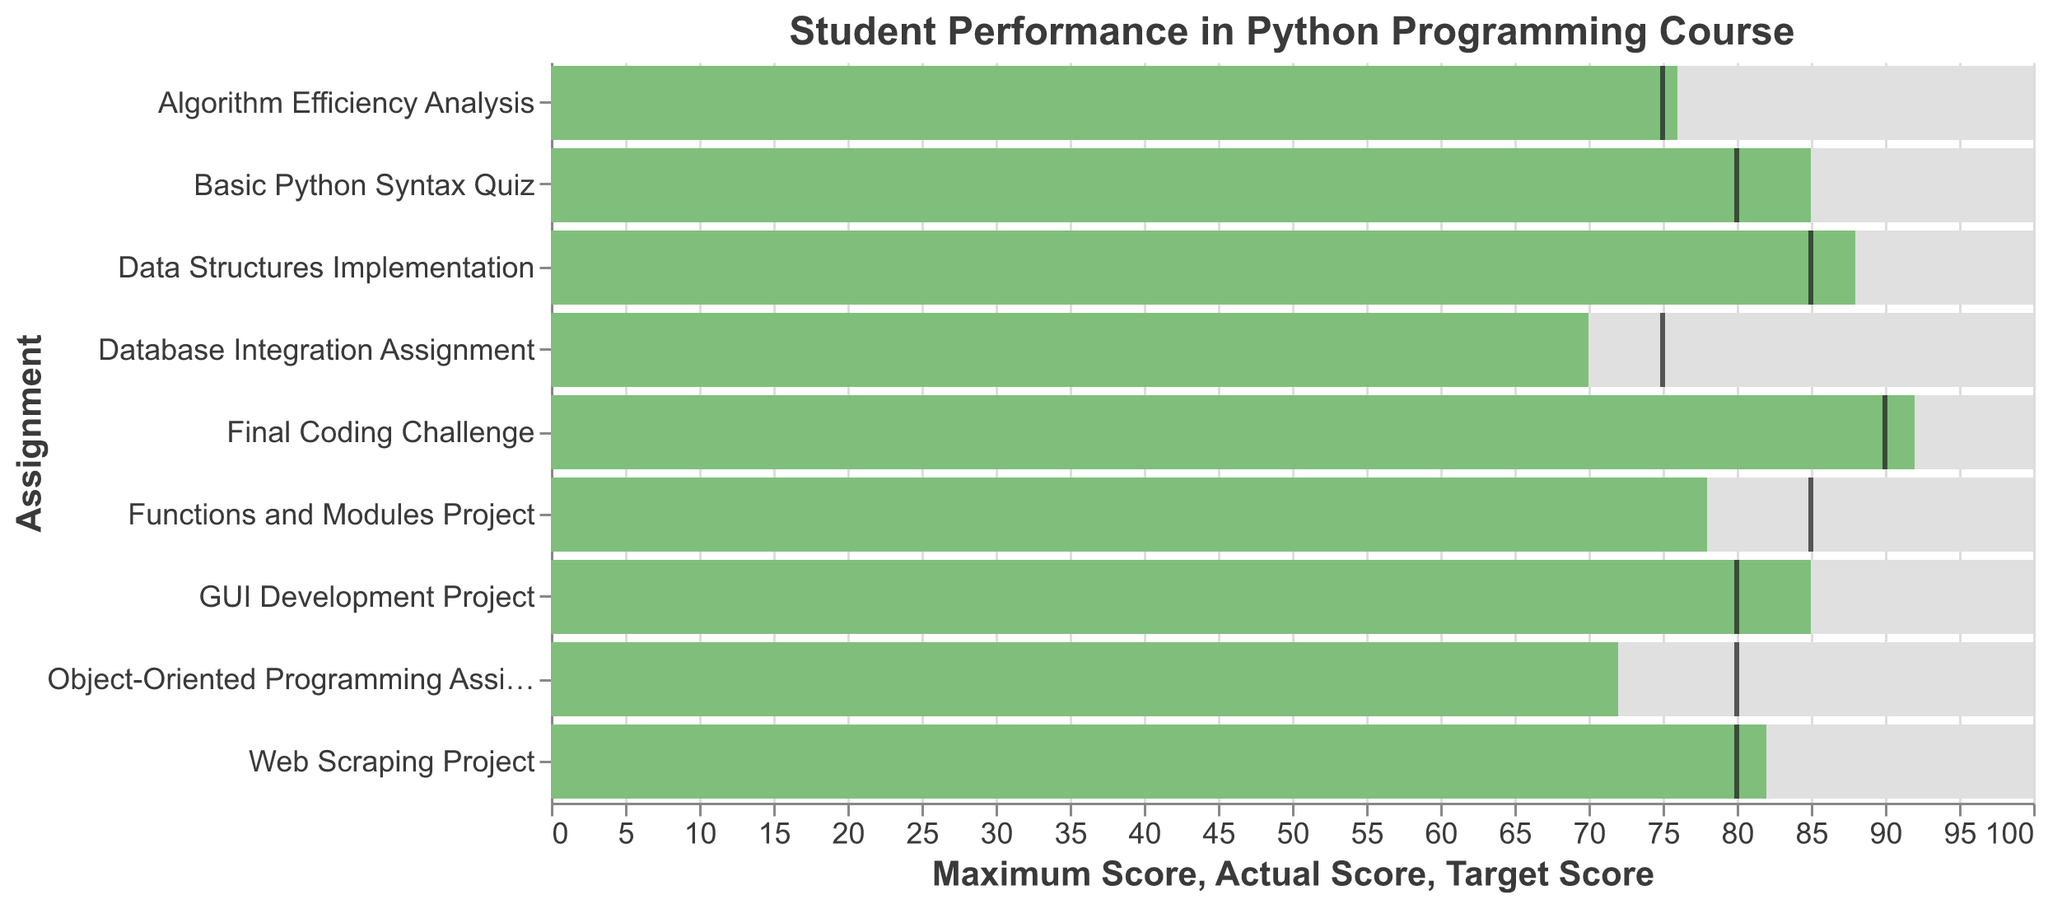Which assignment has the highest actual score? To find the assignment with the highest actual score, look at the green bars representing actual scores. The highest bar belongs to the "Final Coding Challenge."
Answer: Final Coding Challenge What's the target score for the "Data Structures Implementation" assignment? To determine the target score for the "Data Structures Implementation" assignment, find its row and look at the black tick mark's position. The black tick mark aligns at 85.
Answer: 85 Which assignment has the largest difference between actual and target scores? To find the largest difference between actual and target scores, calculate the difference for each assignment: 5 (Basic Python Syntax Quiz), 7 (Functions and Modules Project), 8 (Object-Oriented Programming Assignment), 3 (Data Structures Implementation), 1 (Algorithm Efficiency Analysis), 2 (Web Scraping Project), 5 (Database Integration Assignment), 5 (GUI Development Project), 2 (Final Coding Challenge). The largest difference is 8 for the "Object-Oriented Programming Assignment."
Answer: Object-Oriented Programming Assignment How many assignments did the student meet or exceed the target scores? Compare the bars to the tick marks: Basic Python Syntax Quiz (yes), Functions and Modules Project (no), Object-Oriented Programming Assignment (no), Data Structures Implementation (yes), Algorithm Efficiency Analysis (yes), Web Scraping Project (yes), Database Integration Assignment (no), GUI Development Project (yes), Final Coding Challenge (yes). The student met or exceeded the target in 6 assignments.
Answer: 6 Which assignment has the lowest actual score? To find the lowest actual score, observe the green bars and identify the shortest one. It is for the "Database Integration Assignment."
Answer: Database Integration Assignment What is the average actual score across all assignments? Calculate the average of the actual scores: (85 + 78 + 72 + 88 + 76 + 82 + 70 + 85 + 92) / 9. The sum is 728, so the average is 728/9 ≈ 80.89.
Answer: 80.89 Which assignment had a target score less than its maximum score by exactly 20 points? Assess the target scores and compare them to the maximum scores: Basic Python Syntax Quiz (20), Functions and Modules Project (15), Object-Oriented Programming Assignment (20), Data Structures Implementation (15), Algorithm Efficiency Analysis (25), Web Scraping Project (20), Database Integration Assignment (25), GUI Development Project (20), Final Coding Challenge (10). The assignments are "Basic Python Syntax Quiz," "Object-Oriented Programming Assignment," and "Web Scraping Project."
Answer: Basic Python Syntax Quiz, Object-Oriented Programming Assignment, Web Scraping Project Which assignment shows the student exceeded the target score by the largest margin? Determine the difference between the actual scores and target scores: 5, -7, -8, 3, 1, 2, -5, 5, 2. The largest positive difference is 5, which occurs in "Basic Python Syntax Quiz," "GUI Development Project," and "Algorithm Efficiency Analysis."
Answer: Basic Python Syntax Quiz, GUI Development Project, Algorithm Efficiency Analysis 